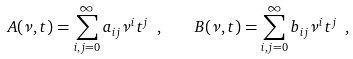Convert formula to latex. <formula><loc_0><loc_0><loc_500><loc_500>A ( \nu , t ) = \sum _ { i , j = 0 } ^ { \infty } a _ { i j } \nu ^ { i } t ^ { j } \ , \quad B ( \nu , t ) = \sum _ { i , j = 0 } ^ { \infty } b _ { i j } \nu ^ { i } t ^ { j } \ ,</formula> 